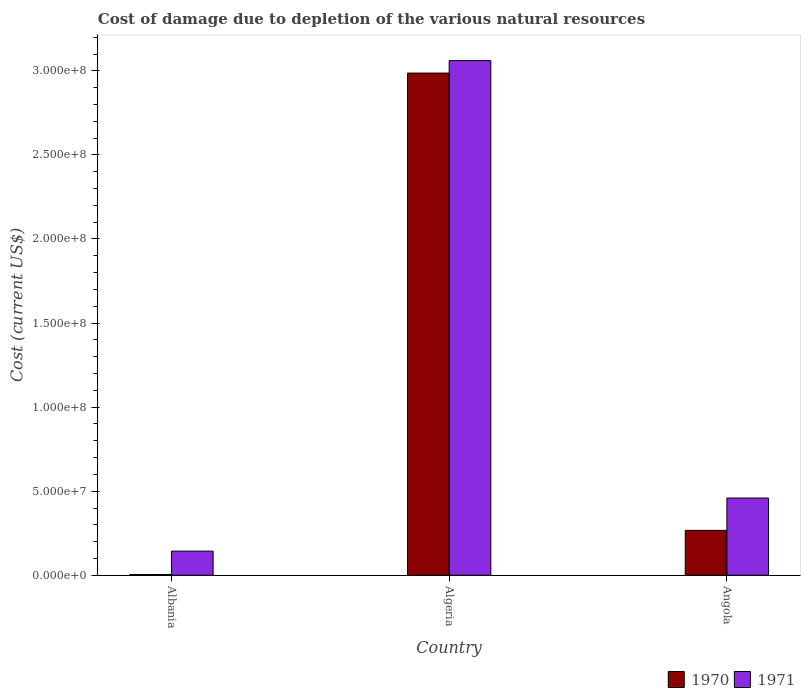How many different coloured bars are there?
Make the answer very short. 2. How many groups of bars are there?
Your answer should be very brief. 3. How many bars are there on the 3rd tick from the right?
Your response must be concise. 2. What is the label of the 3rd group of bars from the left?
Your answer should be very brief. Angola. In how many cases, is the number of bars for a given country not equal to the number of legend labels?
Your response must be concise. 0. What is the cost of damage caused due to the depletion of various natural resources in 1970 in Albania?
Keep it short and to the point. 4.39e+05. Across all countries, what is the maximum cost of damage caused due to the depletion of various natural resources in 1971?
Provide a succinct answer. 3.06e+08. Across all countries, what is the minimum cost of damage caused due to the depletion of various natural resources in 1970?
Your answer should be very brief. 4.39e+05. In which country was the cost of damage caused due to the depletion of various natural resources in 1970 maximum?
Keep it short and to the point. Algeria. In which country was the cost of damage caused due to the depletion of various natural resources in 1970 minimum?
Keep it short and to the point. Albania. What is the total cost of damage caused due to the depletion of various natural resources in 1970 in the graph?
Make the answer very short. 3.26e+08. What is the difference between the cost of damage caused due to the depletion of various natural resources in 1970 in Albania and that in Algeria?
Your response must be concise. -2.98e+08. What is the difference between the cost of damage caused due to the depletion of various natural resources in 1970 in Algeria and the cost of damage caused due to the depletion of various natural resources in 1971 in Angola?
Offer a very short reply. 2.53e+08. What is the average cost of damage caused due to the depletion of various natural resources in 1971 per country?
Offer a very short reply. 1.22e+08. What is the difference between the cost of damage caused due to the depletion of various natural resources of/in 1970 and cost of damage caused due to the depletion of various natural resources of/in 1971 in Angola?
Ensure brevity in your answer.  -1.92e+07. What is the ratio of the cost of damage caused due to the depletion of various natural resources in 1970 in Albania to that in Algeria?
Your response must be concise. 0. Is the difference between the cost of damage caused due to the depletion of various natural resources in 1970 in Albania and Angola greater than the difference between the cost of damage caused due to the depletion of various natural resources in 1971 in Albania and Angola?
Ensure brevity in your answer.  Yes. What is the difference between the highest and the second highest cost of damage caused due to the depletion of various natural resources in 1971?
Keep it short and to the point. 2.92e+08. What is the difference between the highest and the lowest cost of damage caused due to the depletion of various natural resources in 1971?
Provide a succinct answer. 2.92e+08. What does the 2nd bar from the right in Algeria represents?
Offer a terse response. 1970. Are all the bars in the graph horizontal?
Provide a short and direct response. No. How many countries are there in the graph?
Your response must be concise. 3. What is the difference between two consecutive major ticks on the Y-axis?
Your answer should be compact. 5.00e+07. Are the values on the major ticks of Y-axis written in scientific E-notation?
Offer a terse response. Yes. Does the graph contain any zero values?
Ensure brevity in your answer.  No. Does the graph contain grids?
Offer a terse response. No. How are the legend labels stacked?
Provide a short and direct response. Horizontal. What is the title of the graph?
Offer a very short reply. Cost of damage due to depletion of the various natural resources. What is the label or title of the Y-axis?
Offer a very short reply. Cost (current US$). What is the Cost (current US$) in 1970 in Albania?
Offer a terse response. 4.39e+05. What is the Cost (current US$) in 1971 in Albania?
Ensure brevity in your answer.  1.44e+07. What is the Cost (current US$) of 1970 in Algeria?
Your response must be concise. 2.99e+08. What is the Cost (current US$) in 1971 in Algeria?
Offer a terse response. 3.06e+08. What is the Cost (current US$) of 1970 in Angola?
Keep it short and to the point. 2.67e+07. What is the Cost (current US$) in 1971 in Angola?
Offer a terse response. 4.59e+07. Across all countries, what is the maximum Cost (current US$) of 1970?
Offer a terse response. 2.99e+08. Across all countries, what is the maximum Cost (current US$) in 1971?
Give a very brief answer. 3.06e+08. Across all countries, what is the minimum Cost (current US$) in 1970?
Provide a succinct answer. 4.39e+05. Across all countries, what is the minimum Cost (current US$) in 1971?
Your response must be concise. 1.44e+07. What is the total Cost (current US$) of 1970 in the graph?
Provide a succinct answer. 3.26e+08. What is the total Cost (current US$) of 1971 in the graph?
Offer a very short reply. 3.66e+08. What is the difference between the Cost (current US$) of 1970 in Albania and that in Algeria?
Make the answer very short. -2.98e+08. What is the difference between the Cost (current US$) in 1971 in Albania and that in Algeria?
Provide a succinct answer. -2.92e+08. What is the difference between the Cost (current US$) of 1970 in Albania and that in Angola?
Ensure brevity in your answer.  -2.63e+07. What is the difference between the Cost (current US$) of 1971 in Albania and that in Angola?
Your answer should be compact. -3.16e+07. What is the difference between the Cost (current US$) of 1970 in Algeria and that in Angola?
Offer a terse response. 2.72e+08. What is the difference between the Cost (current US$) in 1971 in Algeria and that in Angola?
Your response must be concise. 2.60e+08. What is the difference between the Cost (current US$) in 1970 in Albania and the Cost (current US$) in 1971 in Algeria?
Your answer should be compact. -3.06e+08. What is the difference between the Cost (current US$) in 1970 in Albania and the Cost (current US$) in 1971 in Angola?
Provide a short and direct response. -4.55e+07. What is the difference between the Cost (current US$) of 1970 in Algeria and the Cost (current US$) of 1971 in Angola?
Your answer should be compact. 2.53e+08. What is the average Cost (current US$) of 1970 per country?
Provide a succinct answer. 1.09e+08. What is the average Cost (current US$) of 1971 per country?
Keep it short and to the point. 1.22e+08. What is the difference between the Cost (current US$) of 1970 and Cost (current US$) of 1971 in Albania?
Your answer should be very brief. -1.39e+07. What is the difference between the Cost (current US$) of 1970 and Cost (current US$) of 1971 in Algeria?
Your answer should be compact. -7.42e+06. What is the difference between the Cost (current US$) of 1970 and Cost (current US$) of 1971 in Angola?
Ensure brevity in your answer.  -1.92e+07. What is the ratio of the Cost (current US$) of 1970 in Albania to that in Algeria?
Provide a short and direct response. 0. What is the ratio of the Cost (current US$) of 1971 in Albania to that in Algeria?
Provide a short and direct response. 0.05. What is the ratio of the Cost (current US$) of 1970 in Albania to that in Angola?
Offer a terse response. 0.02. What is the ratio of the Cost (current US$) in 1971 in Albania to that in Angola?
Your answer should be compact. 0.31. What is the ratio of the Cost (current US$) in 1970 in Algeria to that in Angola?
Give a very brief answer. 11.19. What is the ratio of the Cost (current US$) of 1971 in Algeria to that in Angola?
Your response must be concise. 6.66. What is the difference between the highest and the second highest Cost (current US$) in 1970?
Offer a terse response. 2.72e+08. What is the difference between the highest and the second highest Cost (current US$) of 1971?
Keep it short and to the point. 2.60e+08. What is the difference between the highest and the lowest Cost (current US$) of 1970?
Ensure brevity in your answer.  2.98e+08. What is the difference between the highest and the lowest Cost (current US$) in 1971?
Make the answer very short. 2.92e+08. 